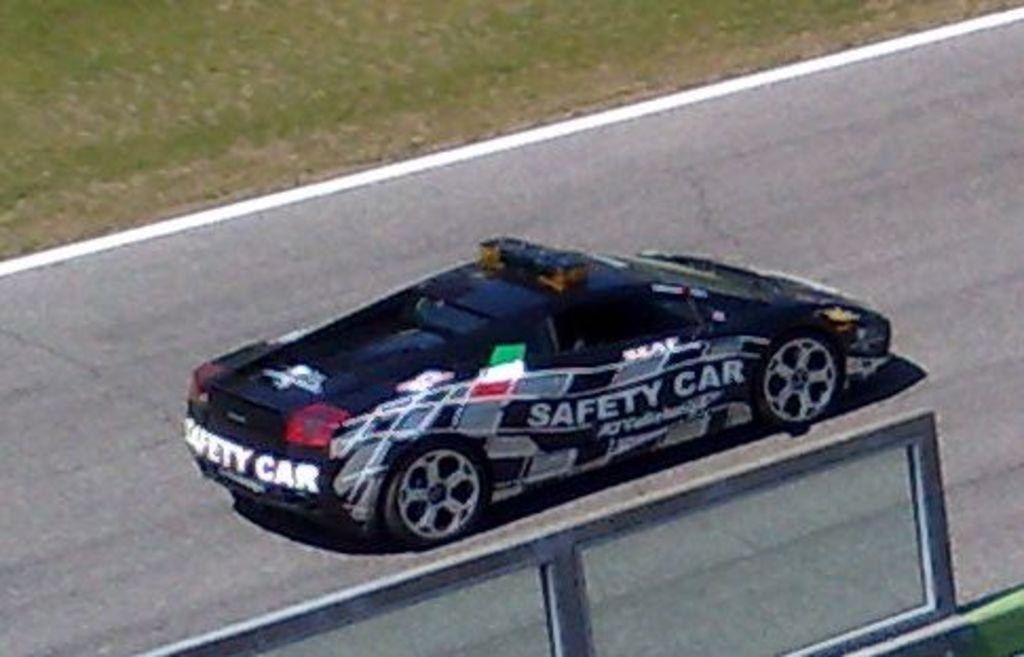What is the main subject of the image? The main subject of the image is a car on the road. Can you describe the setting of the image? The car is on the road, and there is grass visible at the top of the image. What type of crime is being committed near the gate in the image? There is no gate or crime present in the image; it only features a car on the road and grass at the top. 